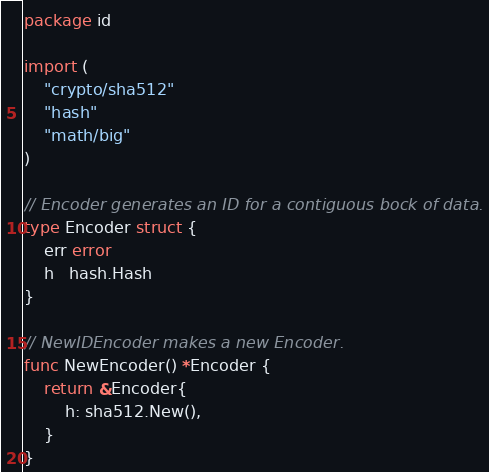<code> <loc_0><loc_0><loc_500><loc_500><_Go_>package id

import (
	"crypto/sha512"
	"hash"
	"math/big"
)

// Encoder generates an ID for a contiguous bock of data.
type Encoder struct {
	err error
	h   hash.Hash
}

// NewIDEncoder makes a new Encoder.
func NewEncoder() *Encoder {
	return &Encoder{
		h: sha512.New(),
	}
}
</code> 